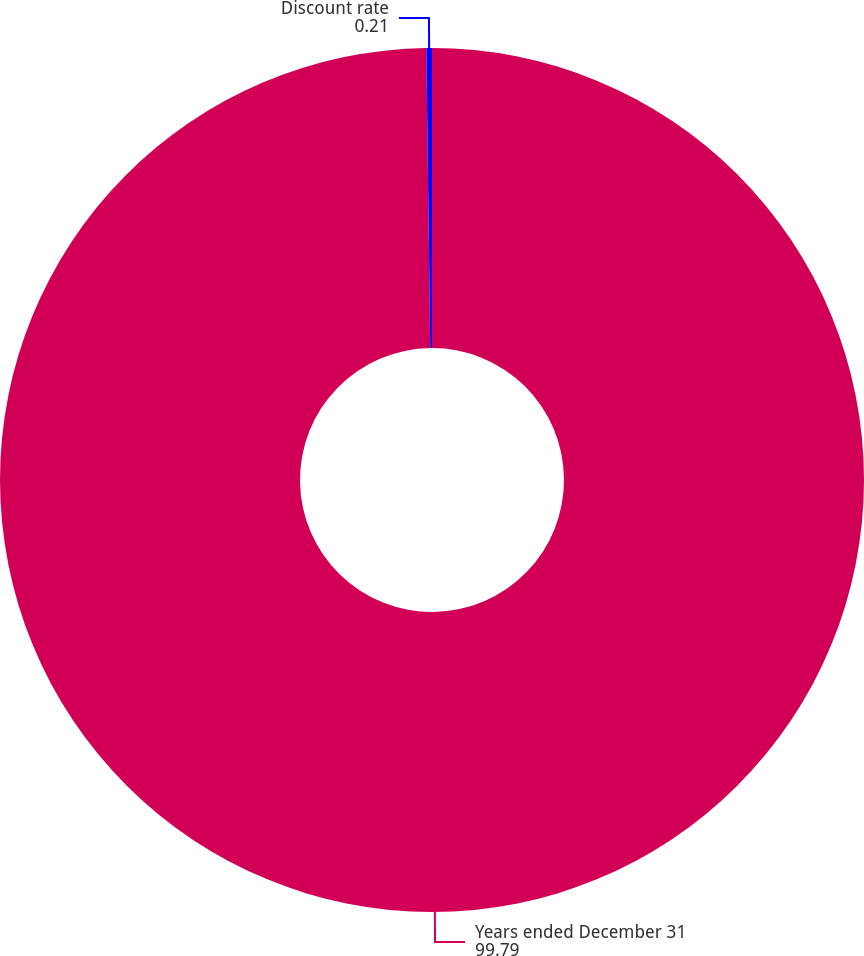<chart> <loc_0><loc_0><loc_500><loc_500><pie_chart><fcel>Years ended December 31<fcel>Discount rate<nl><fcel>99.79%<fcel>0.21%<nl></chart> 